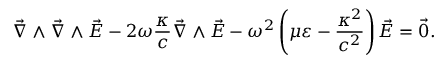Convert formula to latex. <formula><loc_0><loc_0><loc_500><loc_500>\vec { \nabla } \wedge \vec { \nabla } \wedge \vec { E } - 2 \omega \frac { \kappa } { c } \vec { \nabla } \wedge \vec { E } - \omega ^ { 2 } \left ( \mu \varepsilon - \frac { \kappa ^ { 2 } } { c ^ { 2 } } \right ) \vec { E } = \vec { 0 } .</formula> 